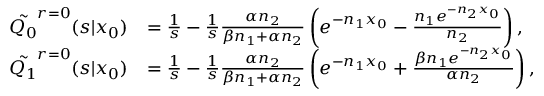Convert formula to latex. <formula><loc_0><loc_0><loc_500><loc_500>\begin{array} { r l } { \tilde { Q _ { 0 } } ^ { r = 0 } ( s | x _ { 0 } ) } & { = \frac { 1 } { s } - \frac { 1 } { s } \frac { \alpha n _ { 2 } } { \beta n _ { 1 } + \alpha n _ { 2 } } \left ( e ^ { - n _ { 1 } x _ { 0 } } - \frac { n _ { 1 } e ^ { - n _ { 2 } x _ { 0 } } } { n _ { 2 } } \right ) , } \\ { \tilde { Q _ { 1 } } ^ { r = 0 } ( s | x _ { 0 } ) } & { = \frac { 1 } { s } - \frac { 1 } { s } \frac { \alpha n _ { 2 } } { \beta n _ { 1 } + \alpha n _ { 2 } } \left ( e ^ { - n _ { 1 } x _ { 0 } } + \frac { \beta n _ { 1 } e ^ { - n _ { 2 } x _ { 0 } } } { \alpha n _ { 2 } } \right ) , } \end{array}</formula> 